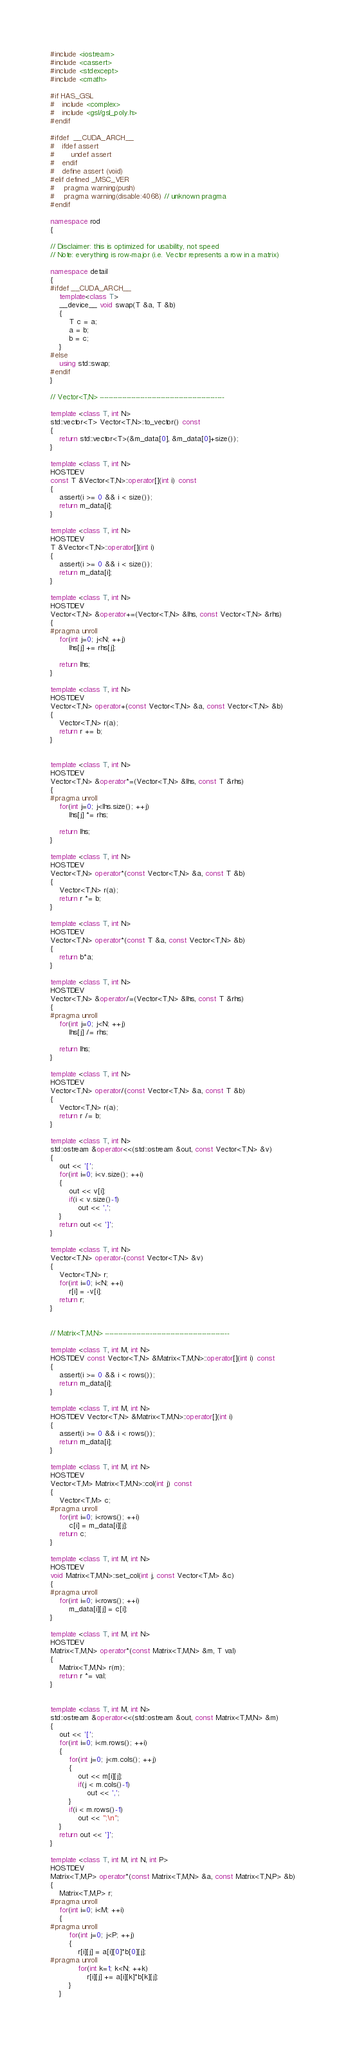<code> <loc_0><loc_0><loc_500><loc_500><_C++_>#include <iostream>
#include <cassert>
#include <stdexcept>
#include <cmath>

#if HAS_GSL
#   include <complex>
#   include <gsl/gsl_poly.h>
#endif

#ifdef  __CUDA_ARCH__
#   ifdef assert
#       undef assert
#   endif
#   define assert (void)
#elif defined _MSC_VER
#	pragma warning(push)
#	pragma warning(disable:4068) // unknown pragma
#endif

namespace rod
{

// Disclaimer: this is optimized for usability, not speed
// Note: everything is row-major (i.e. Vector represents a row in a matrix)

namespace detail
{
#ifdef __CUDA_ARCH__
    template<class T>
    __device__ void swap(T &a, T &b)
    {
        T c = a;
        a = b;
        b = c;
    }
#else
    using std::swap;
#endif
}

// Vector<T,N> -------------------------------------------------------

template <class T, int N>
std::vector<T> Vector<T,N>::to_vector() const
{
    return std::vector<T>(&m_data[0], &m_data[0]+size());
}

template <class T, int N>
HOSTDEV 
const T &Vector<T,N>::operator[](int i) const
{
    assert(i >= 0 && i < size());
    return m_data[i];
}

template <class T, int N>
HOSTDEV 
T &Vector<T,N>::operator[](int i)
{
    assert(i >= 0 && i < size());
    return m_data[i];
}

template <class T, int N>
HOSTDEV 
Vector<T,N> &operator+=(Vector<T,N> &lhs, const Vector<T,N> &rhs)
{
#pragma unroll
    for(int j=0; j<N; ++j)
        lhs[j] += rhs[j];

    return lhs;
}

template <class T, int N>
HOSTDEV 
Vector<T,N> operator+(const Vector<T,N> &a, const Vector<T,N> &b)
{
    Vector<T,N> r(a);
    return r += b;
}


template <class T, int N>
HOSTDEV 
Vector<T,N> &operator*=(Vector<T,N> &lhs, const T &rhs)
{
#pragma unroll
    for(int j=0; j<lhs.size(); ++j)
        lhs[j] *= rhs;

    return lhs;
}

template <class T, int N>
HOSTDEV 
Vector<T,N> operator*(const Vector<T,N> &a, const T &b)
{
    Vector<T,N> r(a);
    return r *= b;
}

template <class T, int N>
HOSTDEV 
Vector<T,N> operator*(const T &a, const Vector<T,N> &b)
{
    return b*a;
}

template <class T, int N>
HOSTDEV 
Vector<T,N> &operator/=(Vector<T,N> &lhs, const T &rhs)
{
#pragma unroll
    for(int j=0; j<N; ++j)
        lhs[j] /= rhs;

    return lhs;
}

template <class T, int N>
HOSTDEV 
Vector<T,N> operator/(const Vector<T,N> &a, const T &b)
{
    Vector<T,N> r(a);
    return r /= b;
}

template <class T, int N>
std::ostream &operator<<(std::ostream &out, const Vector<T,N> &v)
{
    out << '[';
    for(int i=0; i<v.size(); ++i)
    {
        out << v[i];
        if(i < v.size()-1)
            out << ',';
    }
    return out << ']';
}

template <class T, int N>
Vector<T,N> operator-(const Vector<T,N> &v)
{
    Vector<T,N> r;
    for(int i=0; i<N; ++i)
        r[i] = -v[i];
    return r;
}


// Matrix<T,M,N> -------------------------------------------------------

template <class T, int M, int N>
HOSTDEV const Vector<T,N> &Matrix<T,M,N>::operator[](int i) const
{
    assert(i >= 0 && i < rows());
    return m_data[i];
}

template <class T, int M, int N>
HOSTDEV Vector<T,N> &Matrix<T,M,N>::operator[](int i)
{
    assert(i >= 0 && i < rows());
    return m_data[i];
}

template <class T, int M, int N>
HOSTDEV 
Vector<T,M> Matrix<T,M,N>::col(int j) const
{
    Vector<T,M> c;
#pragma unroll
    for(int i=0; i<rows(); ++i)
        c[i] = m_data[i][j];
    return c;
}

template <class T, int M, int N>
HOSTDEV 
void Matrix<T,M,N>::set_col(int j, const Vector<T,M> &c)
{
#pragma unroll
    for(int i=0; i<rows(); ++i)
        m_data[i][j] = c[i];
}

template <class T, int M, int N>
HOSTDEV 
Matrix<T,M,N> operator*(const Matrix<T,M,N> &m, T val)
{
    Matrix<T,M,N> r(m);
    return r *= val;
}


template <class T, int M, int N>
std::ostream &operator<<(std::ostream &out, const Matrix<T,M,N> &m)
{
    out << '[';
    for(int i=0; i<m.rows(); ++i)
    {
        for(int j=0; j<m.cols(); ++j)
        {
            out << m[i][j];
            if(j < m.cols()-1)
                out << ',';
        }
        if(i < m.rows()-1)
            out << ";\n";
    }
    return out << ']';
}

template <class T, int M, int N, int P>
HOSTDEV 
Matrix<T,M,P> operator*(const Matrix<T,M,N> &a, const Matrix<T,N,P> &b)
{
    Matrix<T,M,P> r;
#pragma unroll
    for(int i=0; i<M; ++i)
    {
#pragma unroll
        for(int j=0; j<P; ++j)
        {
            r[i][j] = a[i][0]*b[0][j];
#pragma unroll
            for(int k=1; k<N; ++k)
                r[i][j] += a[i][k]*b[k][j];
        }
    }</code> 